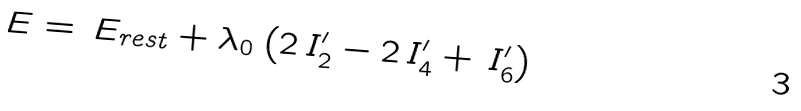<formula> <loc_0><loc_0><loc_500><loc_500>\, E = \, E _ { r e s t } + \lambda _ { 0 } \left ( 2 \, I ^ { \prime } _ { 2 } - 2 \, I ^ { \prime } _ { 4 } + \, I ^ { \prime } _ { 6 } \right )</formula> 